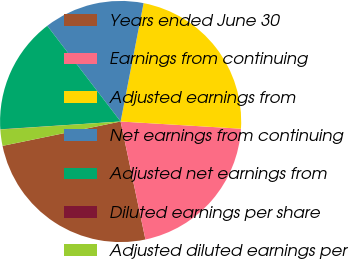Convert chart. <chart><loc_0><loc_0><loc_500><loc_500><pie_chart><fcel>Years ended June 30<fcel>Earnings from continuing<fcel>Adjusted earnings from<fcel>Net earnings from continuing<fcel>Adjusted net earnings from<fcel>Diluted earnings per share<fcel>Adjusted diluted earnings per<nl><fcel>25.06%<fcel>20.75%<fcel>22.9%<fcel>13.46%<fcel>15.62%<fcel>0.03%<fcel>2.18%<nl></chart> 